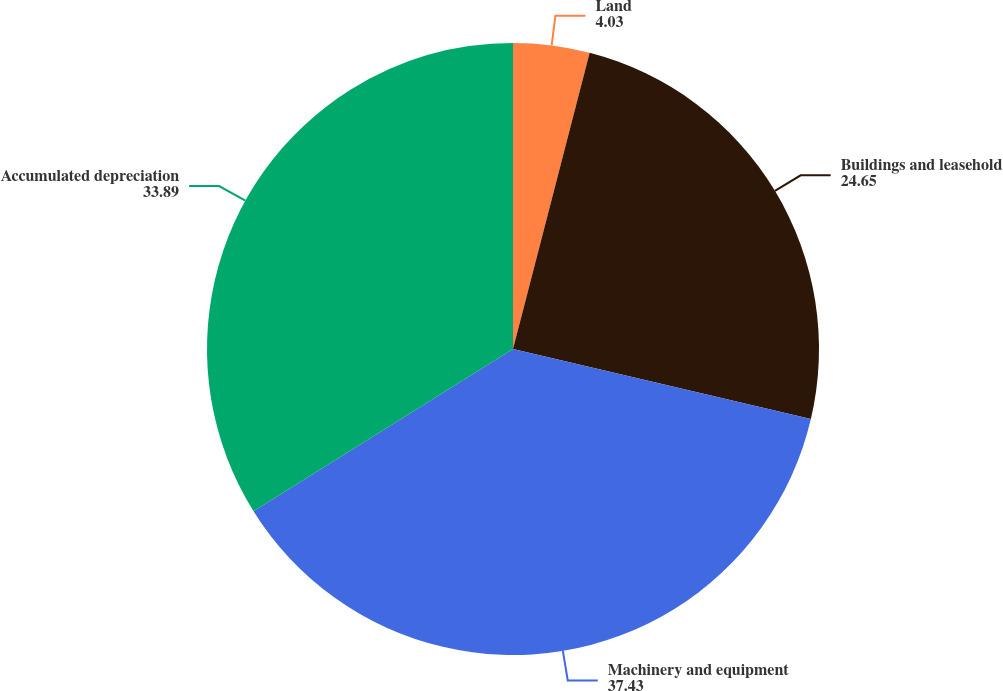Convert chart to OTSL. <chart><loc_0><loc_0><loc_500><loc_500><pie_chart><fcel>Land<fcel>Buildings and leasehold<fcel>Machinery and equipment<fcel>Accumulated depreciation<nl><fcel>4.03%<fcel>24.65%<fcel>37.43%<fcel>33.89%<nl></chart> 